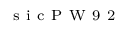Convert formula to latex. <formula><loc_0><loc_0><loc_500><loc_500>_ { s } i c P W 9 2</formula> 